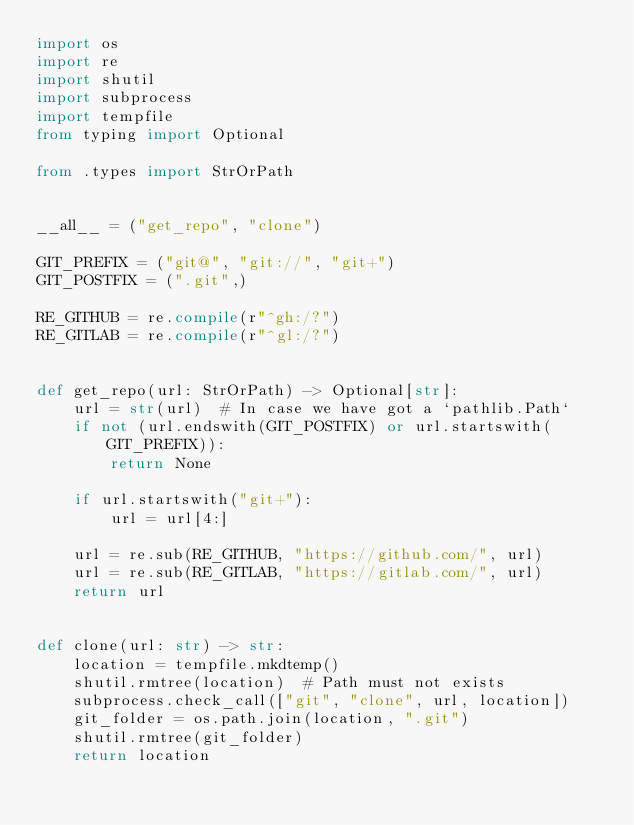Convert code to text. <code><loc_0><loc_0><loc_500><loc_500><_Python_>import os
import re
import shutil
import subprocess
import tempfile
from typing import Optional

from .types import StrOrPath


__all__ = ("get_repo", "clone")

GIT_PREFIX = ("git@", "git://", "git+")
GIT_POSTFIX = (".git",)

RE_GITHUB = re.compile(r"^gh:/?")
RE_GITLAB = re.compile(r"^gl:/?")


def get_repo(url: StrOrPath) -> Optional[str]:
    url = str(url)  # In case we have got a `pathlib.Path`
    if not (url.endswith(GIT_POSTFIX) or url.startswith(GIT_PREFIX)):
        return None

    if url.startswith("git+"):
        url = url[4:]

    url = re.sub(RE_GITHUB, "https://github.com/", url)
    url = re.sub(RE_GITLAB, "https://gitlab.com/", url)
    return url


def clone(url: str) -> str:
    location = tempfile.mkdtemp()
    shutil.rmtree(location)  # Path must not exists
    subprocess.check_call(["git", "clone", url, location])
    git_folder = os.path.join(location, ".git")
    shutil.rmtree(git_folder)
    return location
</code> 